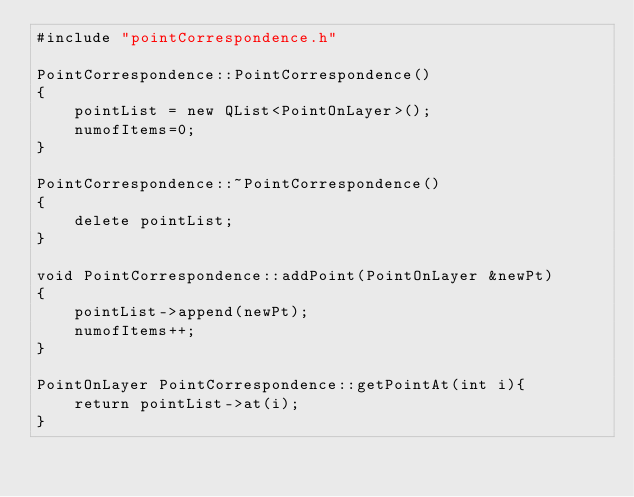<code> <loc_0><loc_0><loc_500><loc_500><_C++_>#include "pointCorrespondence.h"

PointCorrespondence::PointCorrespondence()
{
    pointList = new QList<PointOnLayer>();
    numofItems=0;
}

PointCorrespondence::~PointCorrespondence()
{
    delete pointList;
}

void PointCorrespondence::addPoint(PointOnLayer &newPt)
{
    pointList->append(newPt);
    numofItems++;
}

PointOnLayer PointCorrespondence::getPointAt(int i){
    return pointList->at(i);
}
</code> 